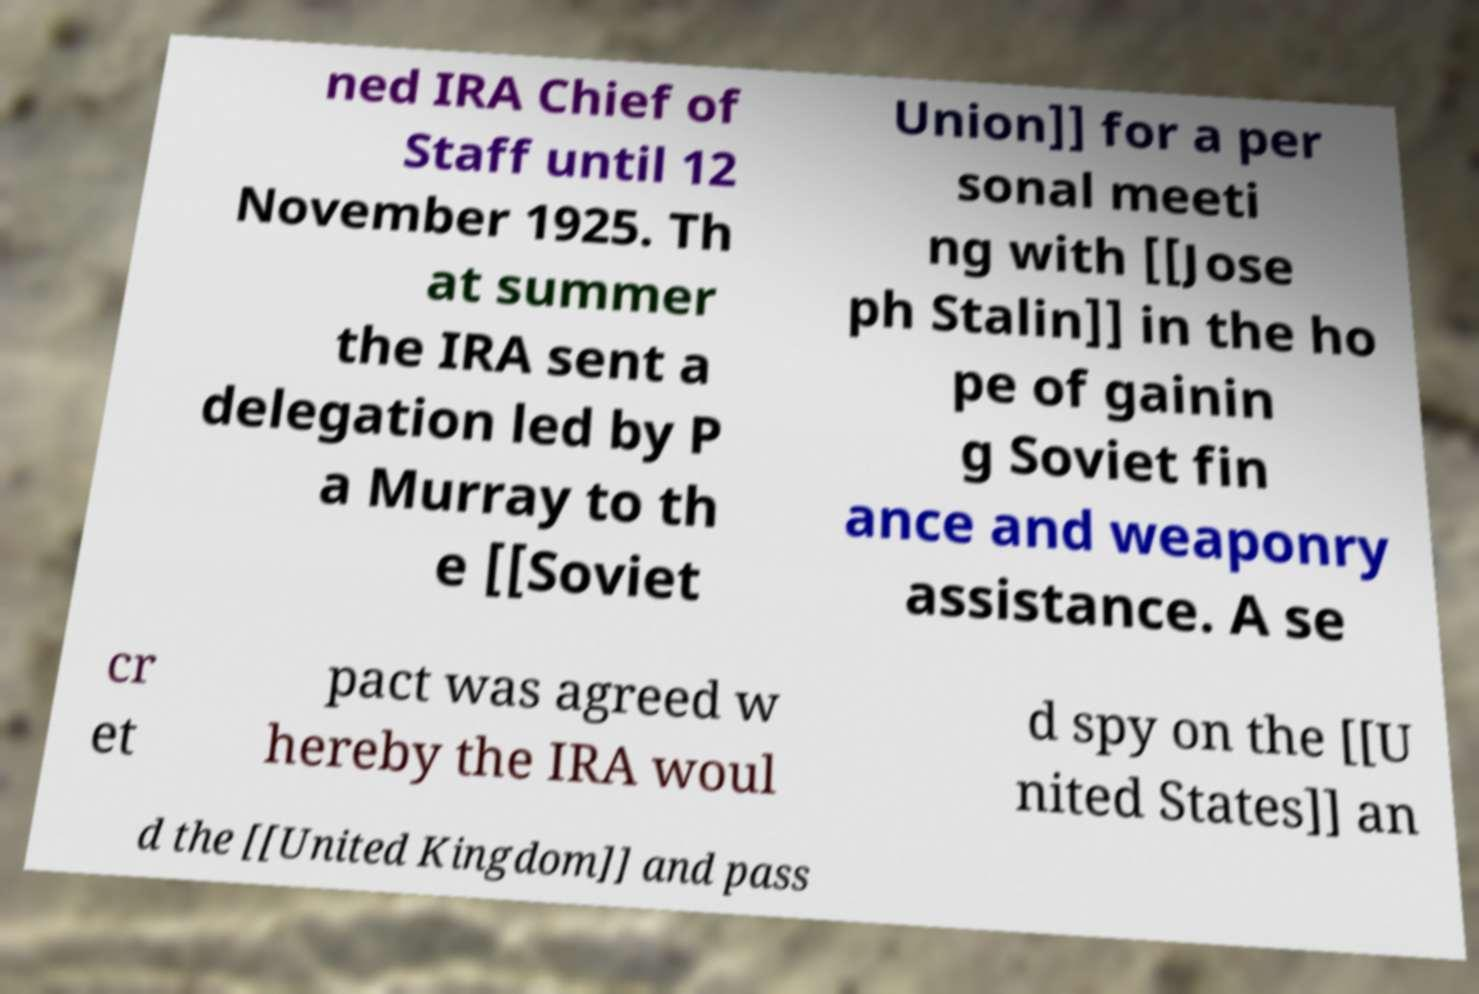Please read and relay the text visible in this image. What does it say? ned IRA Chief of Staff until 12 November 1925. Th at summer the IRA sent a delegation led by P a Murray to th e [[Soviet Union]] for a per sonal meeti ng with [[Jose ph Stalin]] in the ho pe of gainin g Soviet fin ance and weaponry assistance. A se cr et pact was agreed w hereby the IRA woul d spy on the [[U nited States]] an d the [[United Kingdom]] and pass 